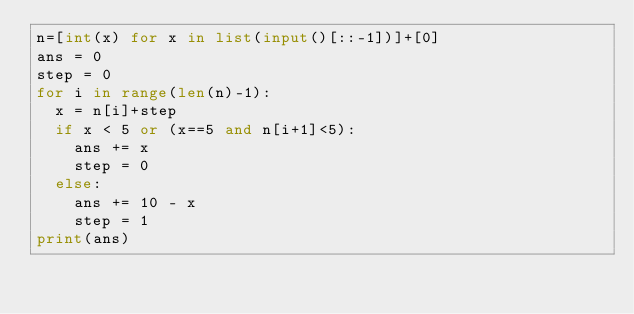<code> <loc_0><loc_0><loc_500><loc_500><_Python_>n=[int(x) for x in list(input()[::-1])]+[0]
ans = 0
step = 0
for i in range(len(n)-1):
  x = n[i]+step
  if x < 5 or (x==5 and n[i+1]<5):
    ans += x
    step = 0
  else:
    ans += 10 - x
    step = 1
print(ans)</code> 